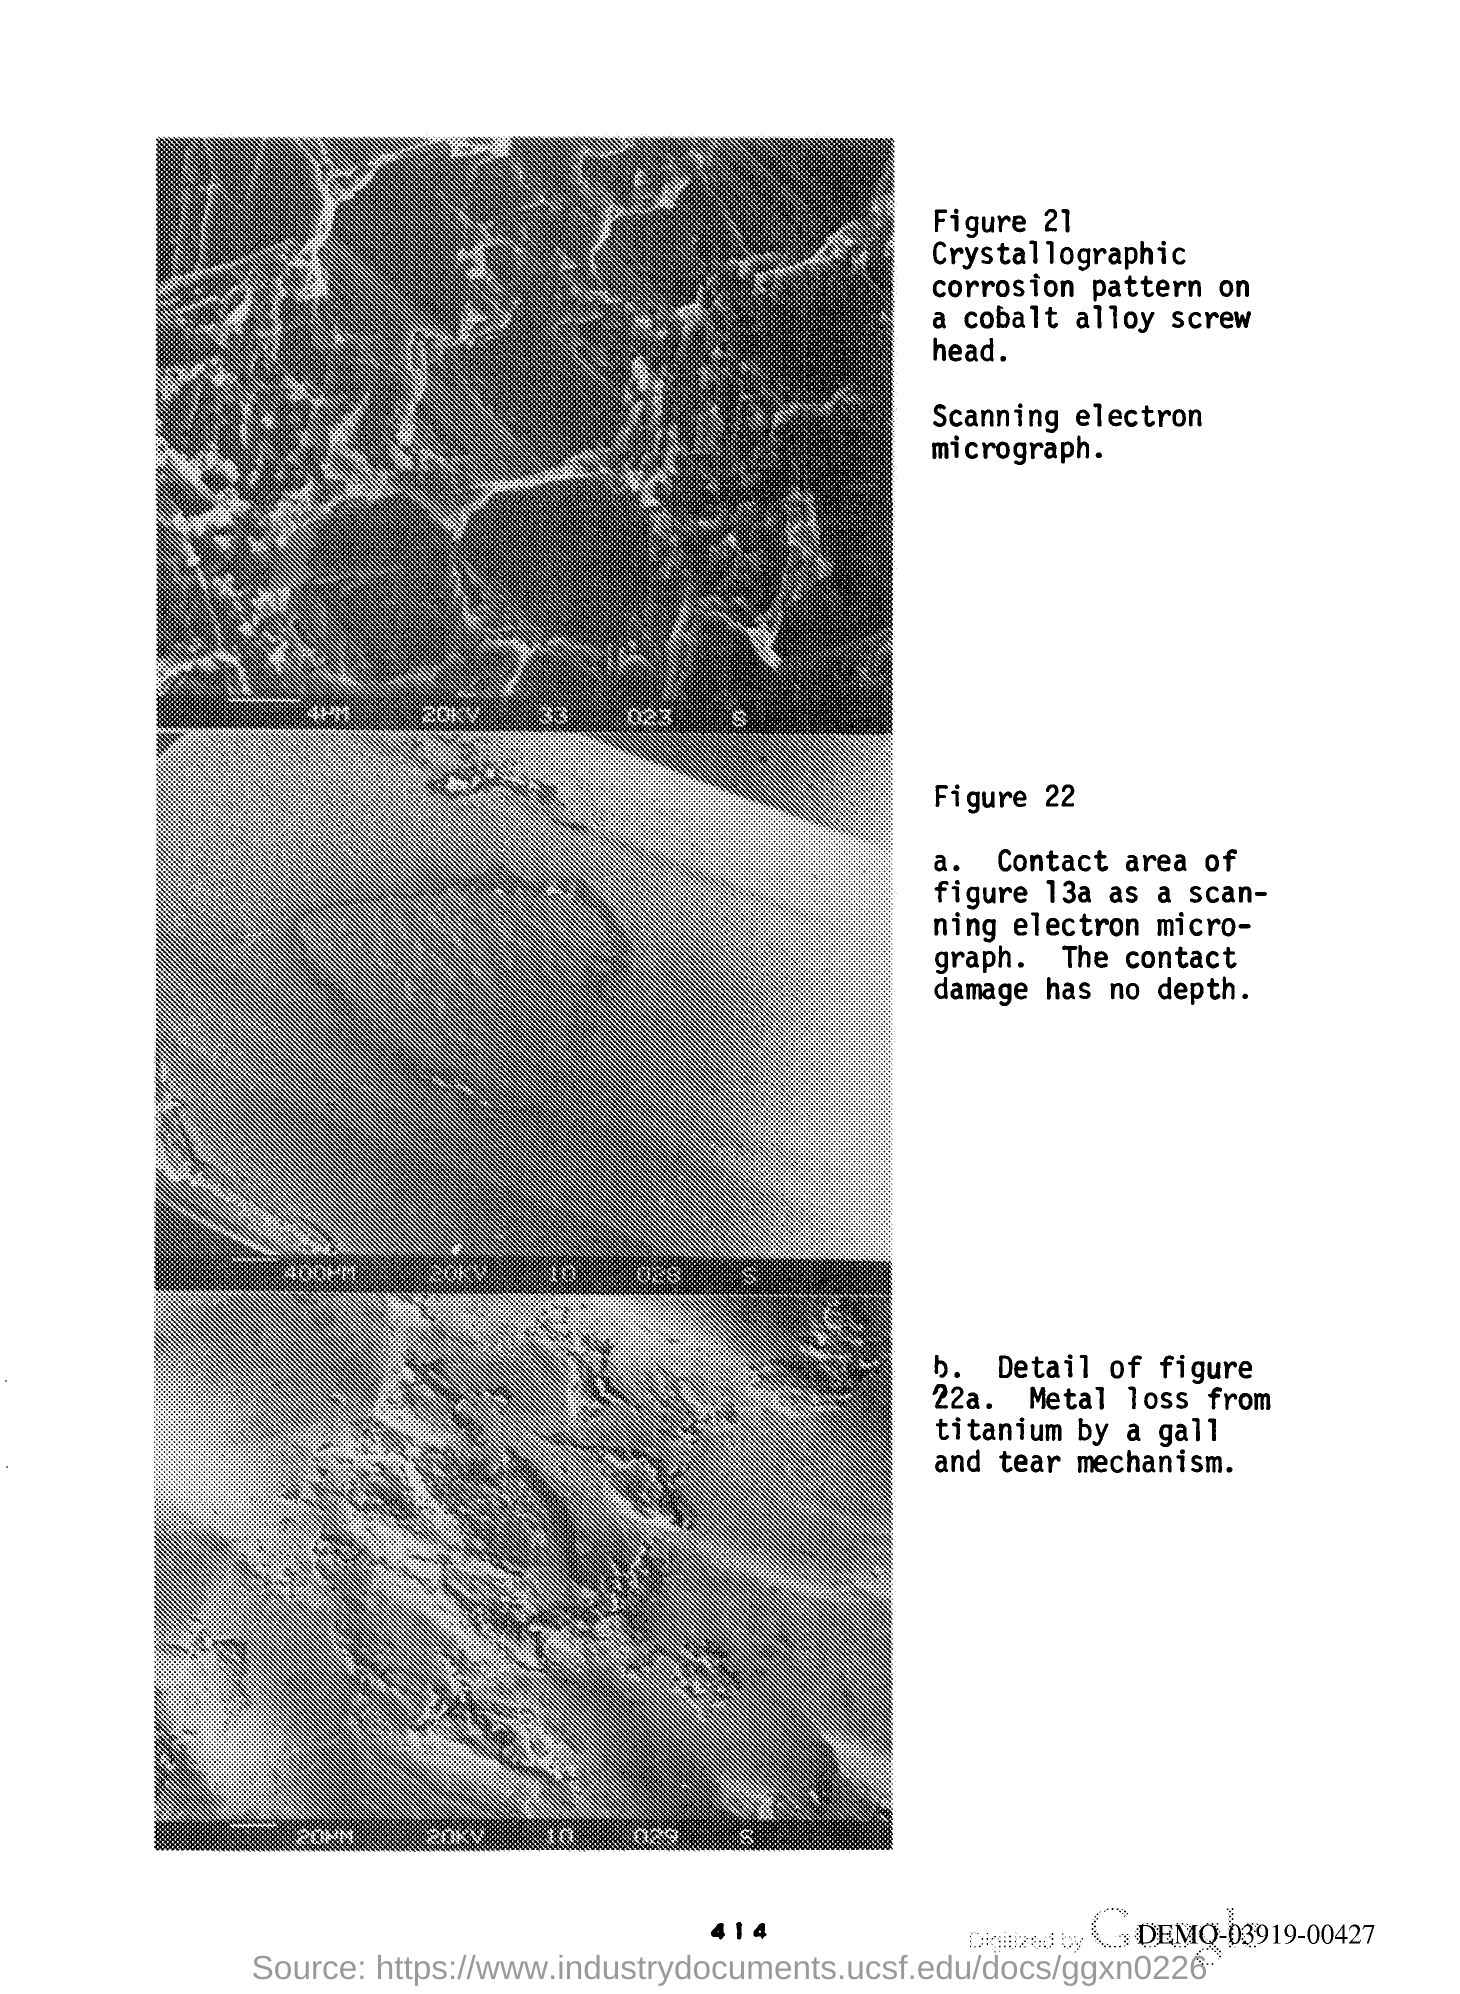Give some essential details in this illustration. The page number is 414. 